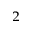Convert formula to latex. <formula><loc_0><loc_0><loc_500><loc_500>^ { 2 }</formula> 